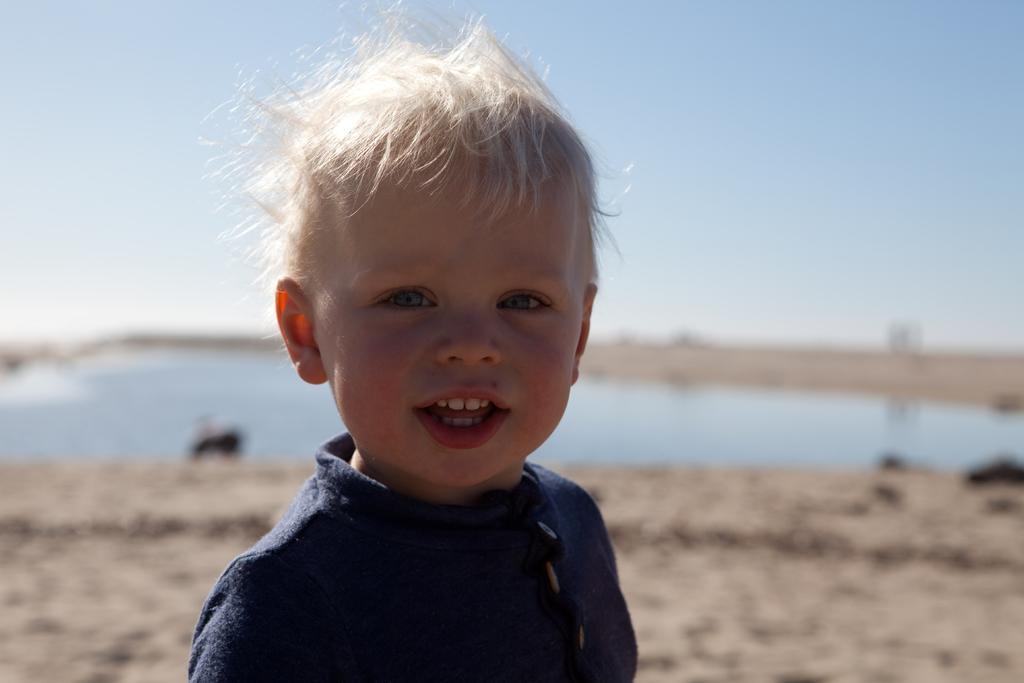In one or two sentences, can you explain what this image depicts? In this image I can see a child wearing blue colored dress. In the background I can see the ground, the water, few black colored objects and the sky. 